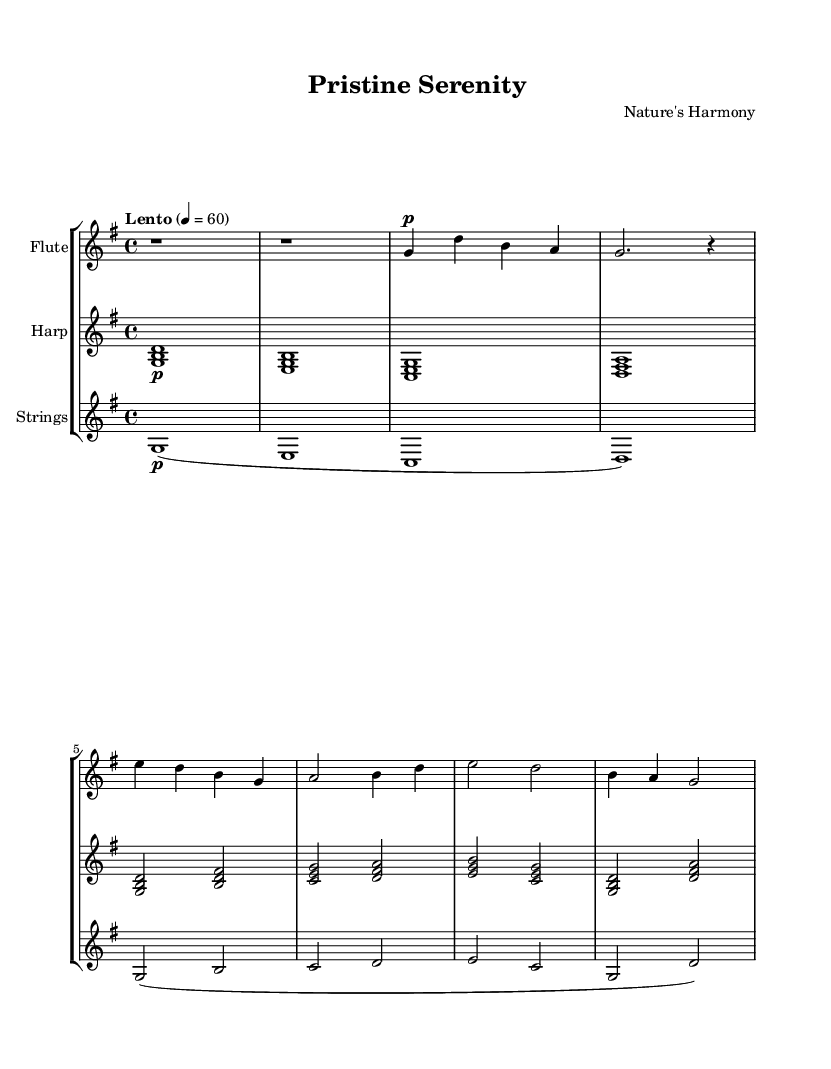What is the key signature of this music? The key signature is G major, which has one sharp (F#). This can be determined by looking at the key signature section at the beginning of the staff.
Answer: G major What is the time signature of this composition? The time signature is 4/4, shown at the beginning of the score. This means there are four beats in each measure, and a quarter note receives one beat.
Answer: 4/4 What is the tempo marking for this piece? The tempo marking is "Lento," which indicates a slow pace. The numerical indication of 60 beats per minute further defines this tempo.
Answer: Lento How many measures are in the flute part? The flute part has a total of seven measures, counted from the beginning of the music to the end of the last measure.
Answer: 7 What is the dynamic marking for the harp? The dynamic marking for the harp is piano (p), indicating that it should be played softly. This marking is placed before the first note and remains consistent throughout.
Answer: piano Which instruments are included in this score? The instruments included in this score are Flute, Harp, and Strings. This can be seen at the beginning of each staff where the instrument names are listed.
Answer: Flute, Harp, Strings Is the flute part primarily melodic or harmonic? The flute part is primarily melodic, as it consists of a single melodic line without any chords or harmonic support. This can be determined by observing how notes are presented in the flute section.
Answer: melodic 